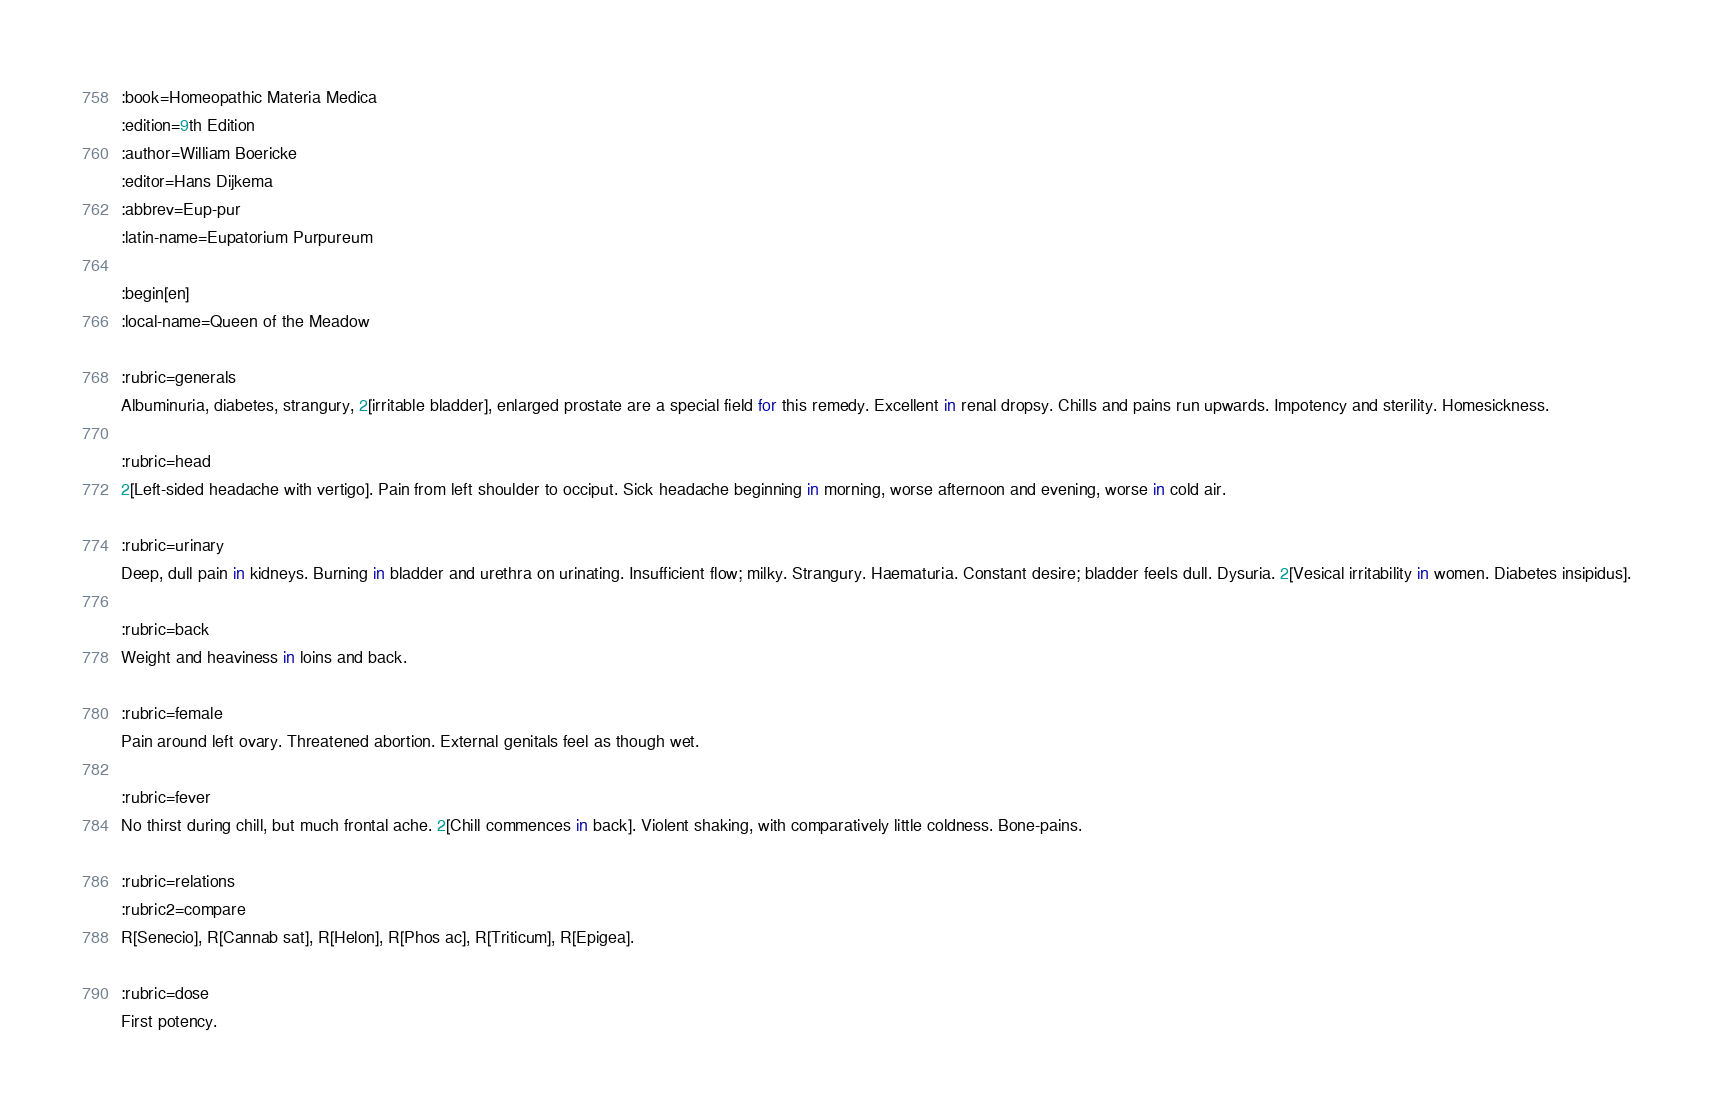<code> <loc_0><loc_0><loc_500><loc_500><_ObjectiveC_>:book=Homeopathic Materia Medica
:edition=9th Edition
:author=William Boericke
:editor=Hans Dijkema
:abbrev=Eup-pur
:latin-name=Eupatorium Purpureum

:begin[en]
:local-name=Queen of the Meadow

:rubric=generals
Albuminuria, diabetes, strangury, 2[irritable bladder], enlarged prostate are a special field for this remedy. Excellent in renal dropsy. Chills and pains run upwards. Impotency and sterility. Homesickness.

:rubric=head
2[Left-sided headache with vertigo]. Pain from left shoulder to occiput. Sick headache beginning in morning, worse afternoon and evening, worse in cold air.

:rubric=urinary
Deep, dull pain in kidneys. Burning in bladder and urethra on urinating. Insufficient flow; milky. Strangury. Haematuria. Constant desire; bladder feels dull. Dysuria. 2[Vesical irritability in women. Diabetes insipidus].

:rubric=back
Weight and heaviness in loins and back.

:rubric=female
Pain around left ovary. Threatened abortion. External genitals feel as though wet.

:rubric=fever
No thirst during chill, but much frontal ache. 2[Chill commences in back]. Violent shaking, with comparatively little coldness. Bone-pains.

:rubric=relations
:rubric2=compare
R[Senecio], R[Cannab sat], R[Helon], R[Phos ac], R[Triticum], R[Epigea].

:rubric=dose
First potency.

</code> 